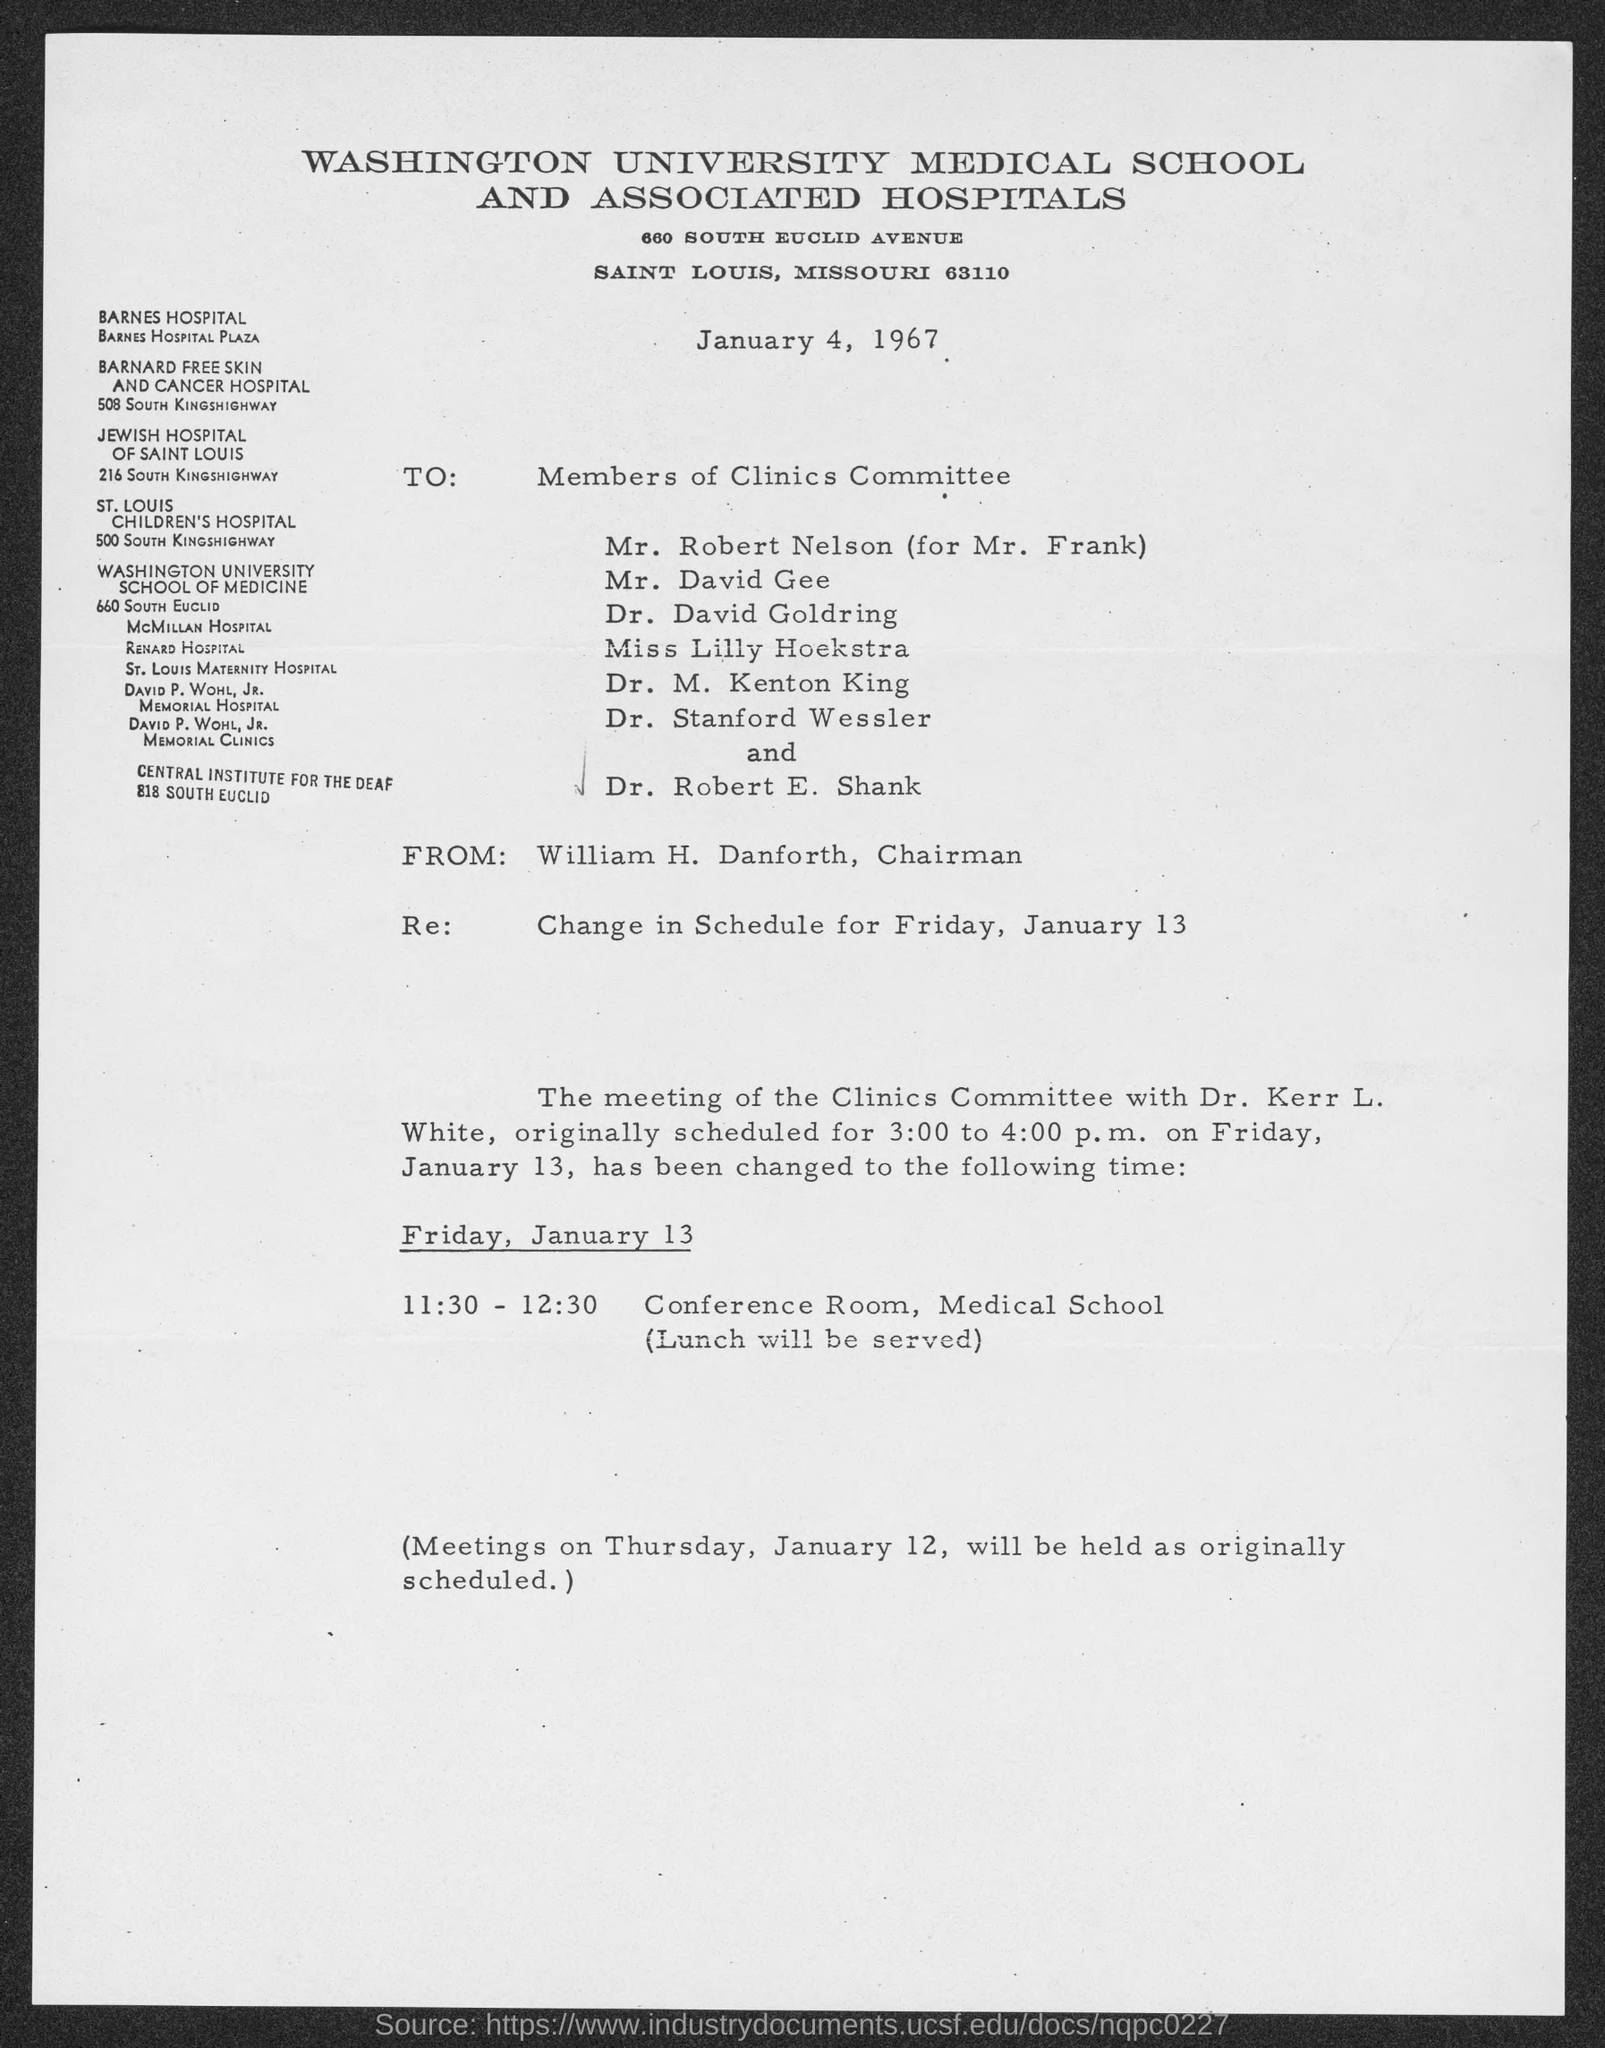Give some essential details in this illustration. William H. Danforth currently holds the position of Chairman. The meeting will take place in the conference room at the Medical School on Friday, January 13. The memorandum was dated January 4, 1967. The subject of the memorandum is the change in schedule for Friday, January 13. 